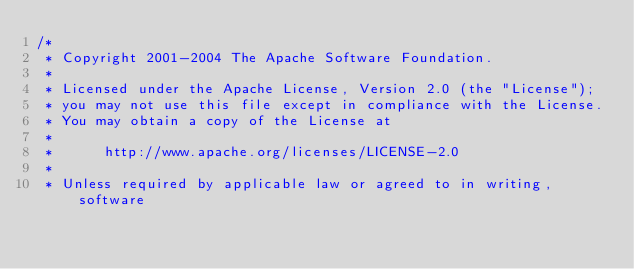Convert code to text. <code><loc_0><loc_0><loc_500><loc_500><_Java_>/*
 * Copyright 2001-2004 The Apache Software Foundation.
 *
 * Licensed under the Apache License, Version 2.0 (the "License");
 * you may not use this file except in compliance with the License.
 * You may obtain a copy of the License at
 *
 *      http://www.apache.org/licenses/LICENSE-2.0
 *
 * Unless required by applicable law or agreed to in writing, software</code> 